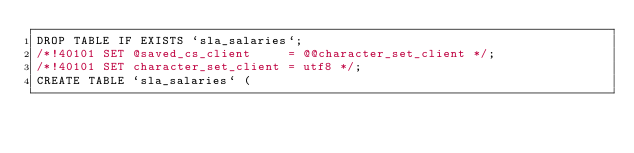<code> <loc_0><loc_0><loc_500><loc_500><_SQL_>DROP TABLE IF EXISTS `sla_salaries`;
/*!40101 SET @saved_cs_client     = @@character_set_client */;
/*!40101 SET character_set_client = utf8 */;
CREATE TABLE `sla_salaries` (</code> 